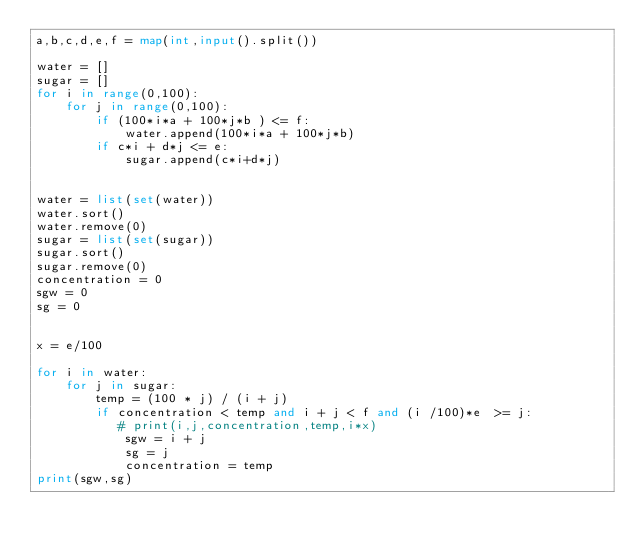<code> <loc_0><loc_0><loc_500><loc_500><_Python_>a,b,c,d,e,f = map(int,input().split())

water = []
sugar = []
for i in range(0,100):
    for j in range(0,100):
        if (100*i*a + 100*j*b ) <= f:
            water.append(100*i*a + 100*j*b)
        if c*i + d*j <= e:
            sugar.append(c*i+d*j)
        

water = list(set(water))
water.sort()
water.remove(0)
sugar = list(set(sugar))
sugar.sort()
sugar.remove(0)
concentration = 0
sgw = 0
sg = 0


x = e/100

for i in water:
    for j in sugar:
        temp = (100 * j) / (i + j)
        if concentration < temp and i + j < f and (i /100)*e  >= j:
           # print(i,j,concentration,temp,i*x)
            sgw = i + j
            sg = j
            concentration = temp
print(sgw,sg)

</code> 